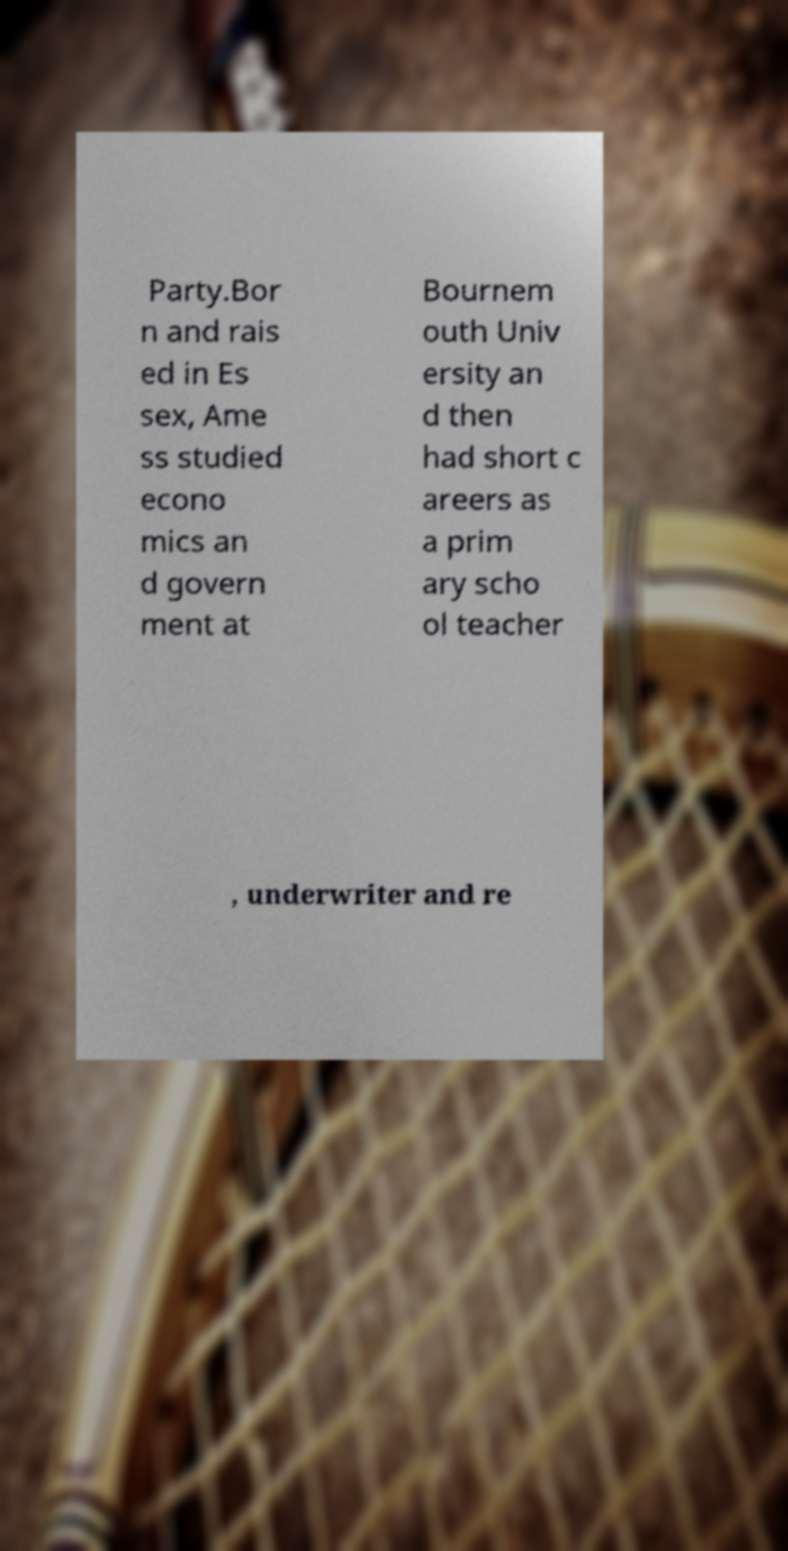Could you extract and type out the text from this image? Party.Bor n and rais ed in Es sex, Ame ss studied econo mics an d govern ment at Bournem outh Univ ersity an d then had short c areers as a prim ary scho ol teacher , underwriter and re 